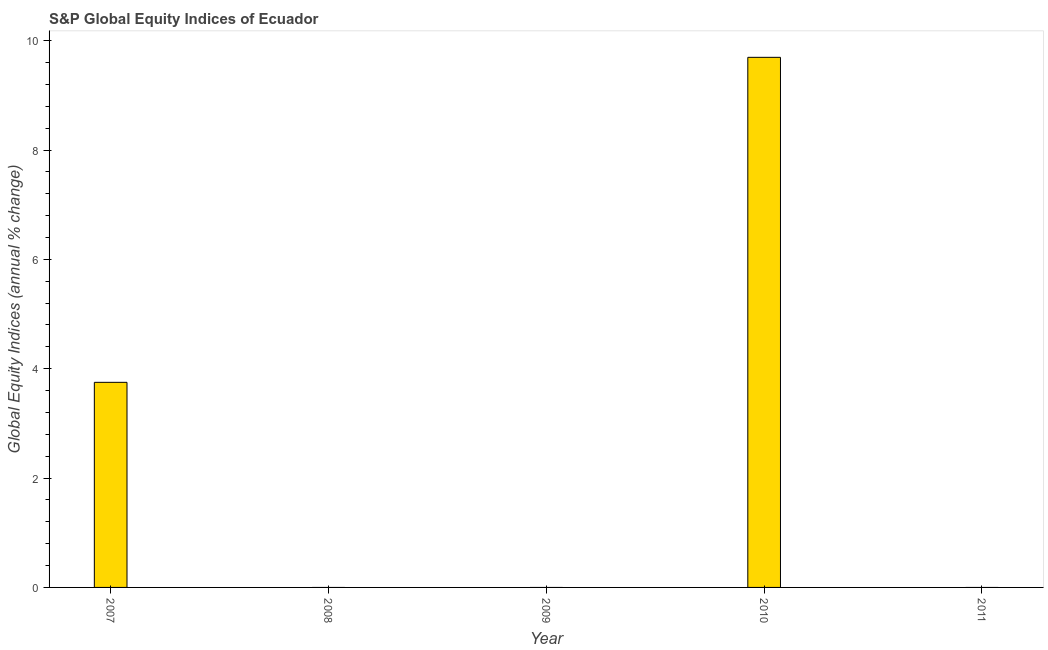Does the graph contain any zero values?
Offer a terse response. Yes. Does the graph contain grids?
Your response must be concise. No. What is the title of the graph?
Provide a short and direct response. S&P Global Equity Indices of Ecuador. What is the label or title of the X-axis?
Provide a short and direct response. Year. What is the label or title of the Y-axis?
Keep it short and to the point. Global Equity Indices (annual % change). What is the s&p global equity indices in 2011?
Give a very brief answer. 0. Across all years, what is the maximum s&p global equity indices?
Make the answer very short. 9.69. Across all years, what is the minimum s&p global equity indices?
Make the answer very short. 0. In which year was the s&p global equity indices maximum?
Your answer should be very brief. 2010. What is the sum of the s&p global equity indices?
Ensure brevity in your answer.  13.45. What is the difference between the s&p global equity indices in 2007 and 2010?
Make the answer very short. -5.94. What is the average s&p global equity indices per year?
Your answer should be compact. 2.69. What is the median s&p global equity indices?
Offer a very short reply. 0. What is the ratio of the s&p global equity indices in 2007 to that in 2010?
Provide a succinct answer. 0.39. What is the difference between the highest and the lowest s&p global equity indices?
Make the answer very short. 9.69. How many bars are there?
Make the answer very short. 2. Are all the bars in the graph horizontal?
Give a very brief answer. No. Are the values on the major ticks of Y-axis written in scientific E-notation?
Ensure brevity in your answer.  No. What is the Global Equity Indices (annual % change) of 2007?
Your answer should be very brief. 3.75. What is the Global Equity Indices (annual % change) of 2008?
Offer a very short reply. 0. What is the Global Equity Indices (annual % change) in 2009?
Make the answer very short. 0. What is the Global Equity Indices (annual % change) of 2010?
Make the answer very short. 9.69. What is the difference between the Global Equity Indices (annual % change) in 2007 and 2010?
Provide a short and direct response. -5.94. What is the ratio of the Global Equity Indices (annual % change) in 2007 to that in 2010?
Keep it short and to the point. 0.39. 